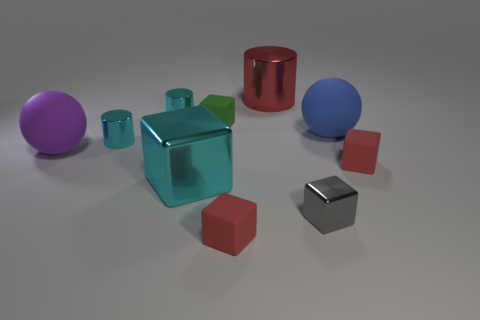Subtract 1 blocks. How many blocks are left? 4 Subtract all green cubes. How many cubes are left? 4 Subtract all brown blocks. Subtract all gray spheres. How many blocks are left? 5 Subtract all cylinders. How many objects are left? 7 Add 6 big blue rubber things. How many big blue rubber things are left? 7 Add 10 big brown objects. How many big brown objects exist? 10 Subtract 1 cyan blocks. How many objects are left? 9 Subtract all purple balls. Subtract all large purple balls. How many objects are left? 8 